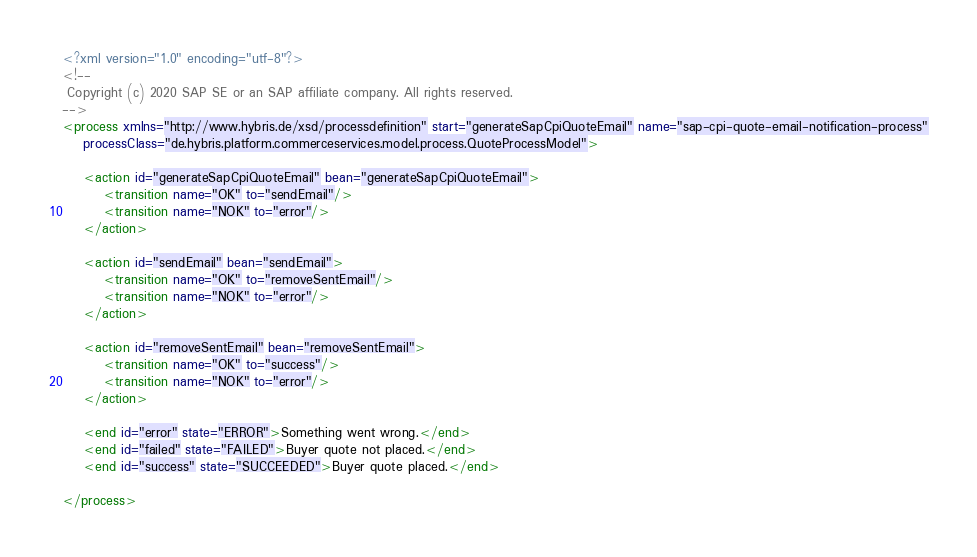Convert code to text. <code><loc_0><loc_0><loc_500><loc_500><_XML_><?xml version="1.0" encoding="utf-8"?>
<!--
 Copyright (c) 2020 SAP SE or an SAP affiliate company. All rights reserved.
-->
<process xmlns="http://www.hybris.de/xsd/processdefinition" start="generateSapCpiQuoteEmail" name="sap-cpi-quote-email-notification-process"
	processClass="de.hybris.platform.commerceservices.model.process.QuoteProcessModel">
	
	<action id="generateSapCpiQuoteEmail" bean="generateSapCpiQuoteEmail">
        <transition name="OK" to="sendEmail"/>
        <transition name="NOK" to="error"/>
    </action>

    <action id="sendEmail" bean="sendEmail">
        <transition name="OK" to="removeSentEmail"/>
        <transition name="NOK" to="error"/>
    </action>

    <action id="removeSentEmail" bean="removeSentEmail">
        <transition name="OK" to="success"/>
        <transition name="NOK" to="error"/>
    </action>

    <end id="error" state="ERROR">Something went wrong.</end>
    <end id="failed" state="FAILED">Buyer quote not placed.</end>
    <end id="success" state="SUCCEEDED">Buyer quote placed.</end>

</process>
</code> 